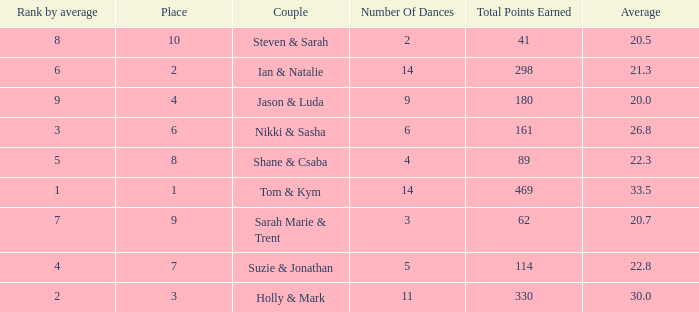What is the number of dances total number if the average is 22.3? 1.0. 